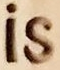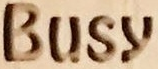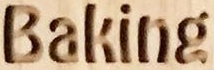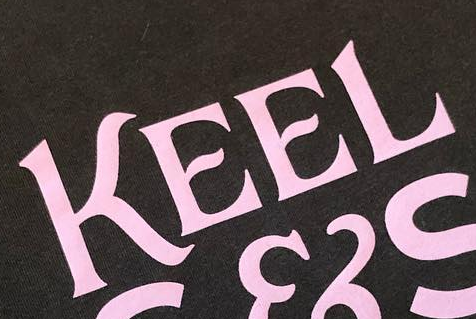What words can you see in these images in sequence, separated by a semicolon? is; Busy; Baking; KEEL 